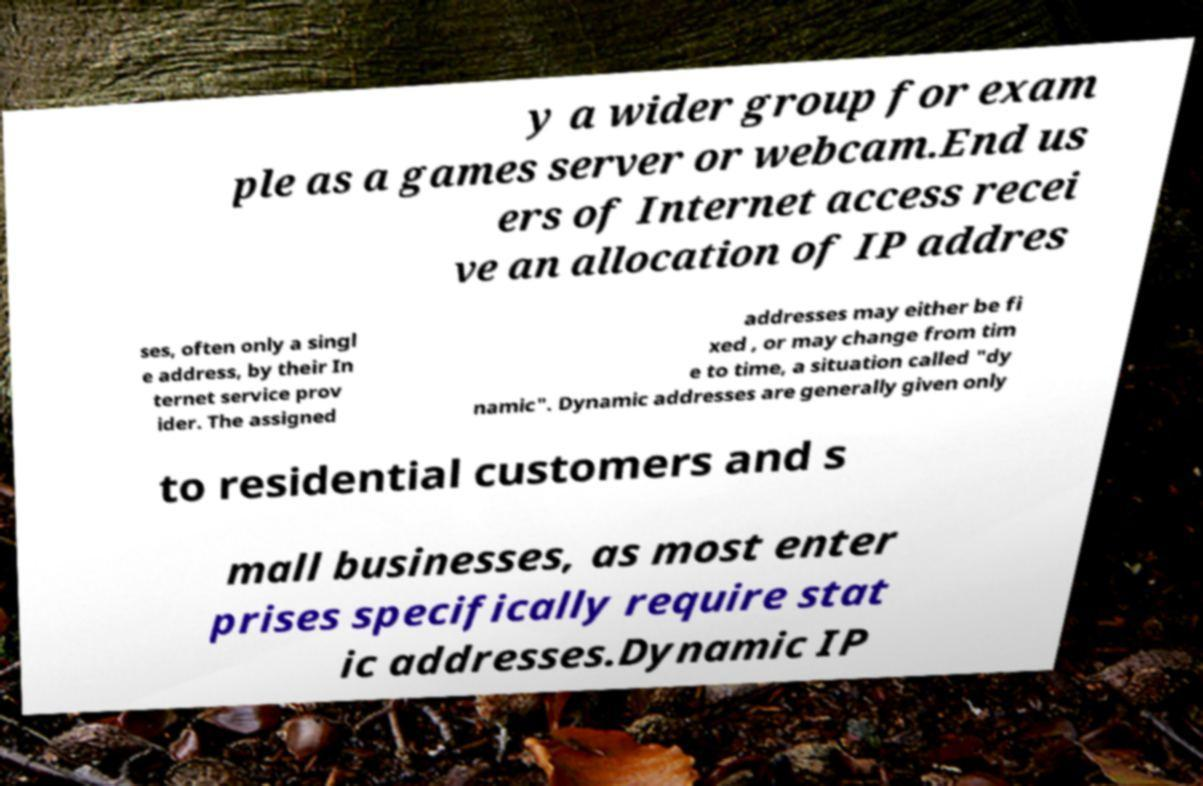Could you assist in decoding the text presented in this image and type it out clearly? y a wider group for exam ple as a games server or webcam.End us ers of Internet access recei ve an allocation of IP addres ses, often only a singl e address, by their In ternet service prov ider. The assigned addresses may either be fi xed , or may change from tim e to time, a situation called "dy namic". Dynamic addresses are generally given only to residential customers and s mall businesses, as most enter prises specifically require stat ic addresses.Dynamic IP 